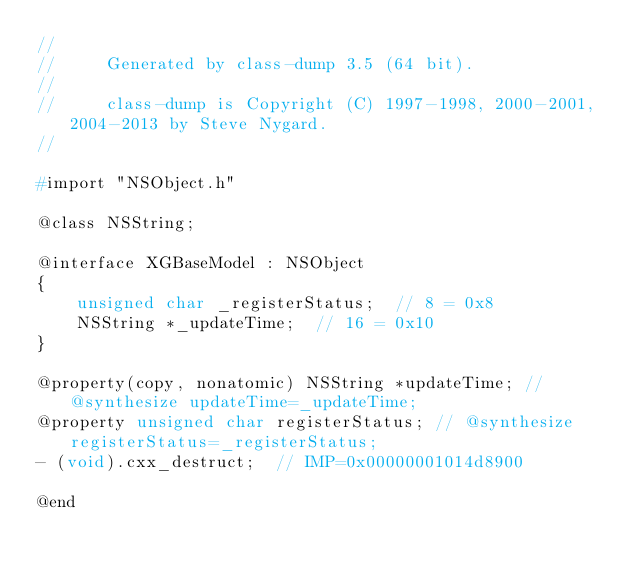<code> <loc_0><loc_0><loc_500><loc_500><_C_>//
//     Generated by class-dump 3.5 (64 bit).
//
//     class-dump is Copyright (C) 1997-1998, 2000-2001, 2004-2013 by Steve Nygard.
//

#import "NSObject.h"

@class NSString;

@interface XGBaseModel : NSObject
{
    unsigned char _registerStatus;	// 8 = 0x8
    NSString *_updateTime;	// 16 = 0x10
}

@property(copy, nonatomic) NSString *updateTime; // @synthesize updateTime=_updateTime;
@property unsigned char registerStatus; // @synthesize registerStatus=_registerStatus;
- (void).cxx_destruct;	// IMP=0x00000001014d8900

@end

</code> 